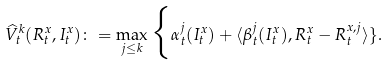<formula> <loc_0><loc_0><loc_500><loc_500>\widehat { V } _ { t } ^ { k } ( R ^ { x } _ { t } , I ^ { x } _ { t } ) \colon = \max _ { j \leq k } \Big \{ \alpha ^ { j } _ { t } ( I ^ { x } _ { t } ) + \langle \beta ^ { j } _ { t } ( I ^ { x } _ { t } ) , R ^ { x } _ { t } - R ^ { x , j } _ { t } \rangle \} .</formula> 